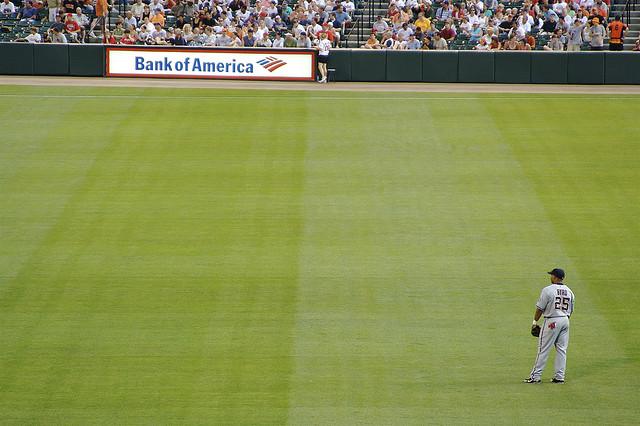What company's name is on the banner?
Answer briefly. Bank of america. How many people are on the field?
Short answer required. 1. What kind of terrain is he playing on?
Answer briefly. Grass. Are the stands full?
Short answer required. Yes. 